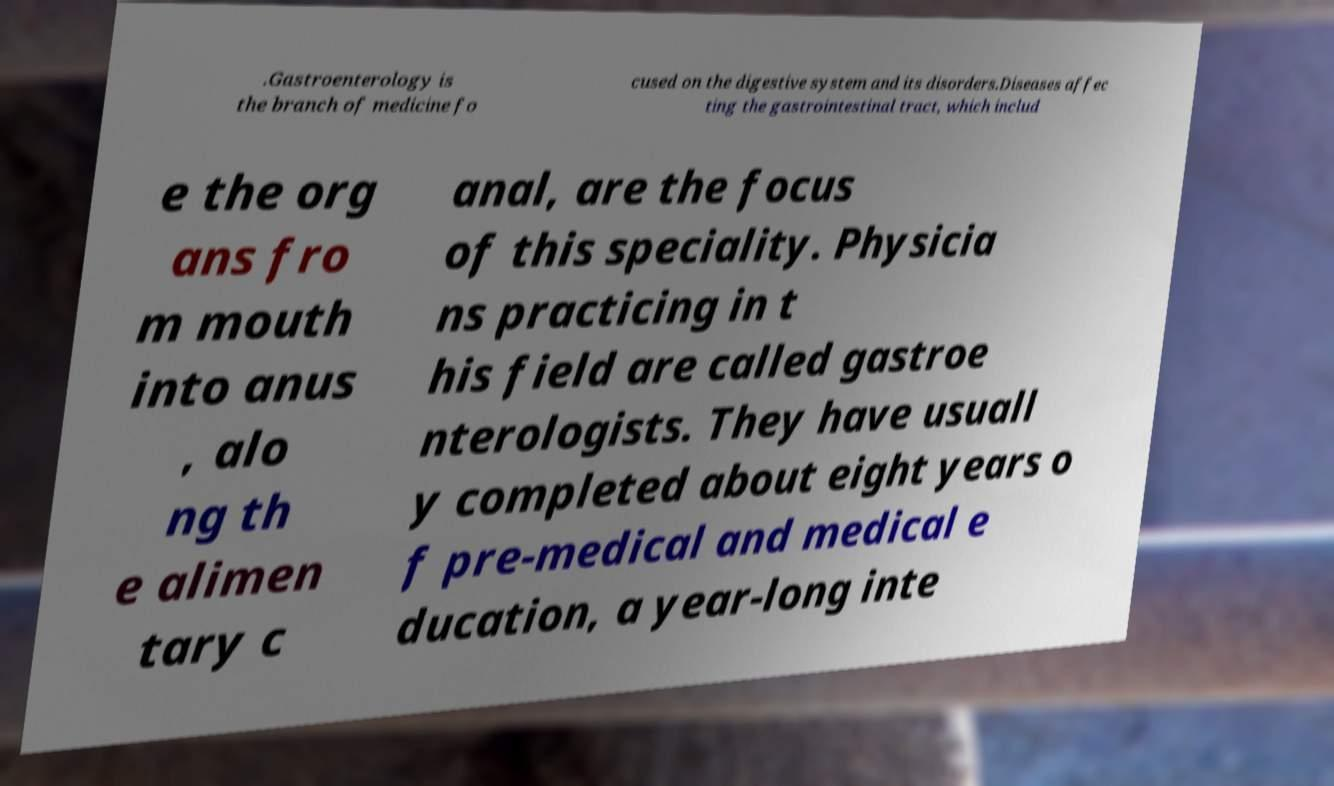What messages or text are displayed in this image? I need them in a readable, typed format. .Gastroenterology is the branch of medicine fo cused on the digestive system and its disorders.Diseases affec ting the gastrointestinal tract, which includ e the org ans fro m mouth into anus , alo ng th e alimen tary c anal, are the focus of this speciality. Physicia ns practicing in t his field are called gastroe nterologists. They have usuall y completed about eight years o f pre-medical and medical e ducation, a year-long inte 